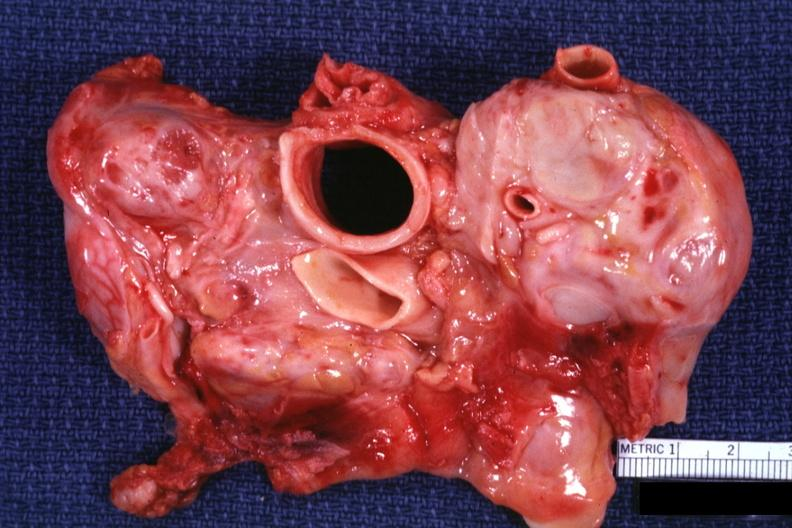does this image show cross section trachea and aorta with massive node metastases can not see cava could be a lymphoma also?
Answer the question using a single word or phrase. Yes 